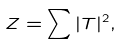<formula> <loc_0><loc_0><loc_500><loc_500>Z = \sum | T | ^ { 2 } ,</formula> 